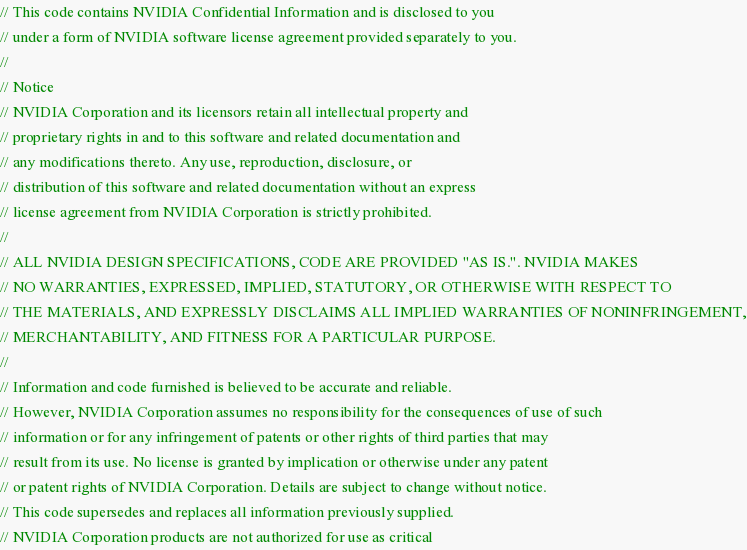Convert code to text. <code><loc_0><loc_0><loc_500><loc_500><_C_>// This code contains NVIDIA Confidential Information and is disclosed to you
// under a form of NVIDIA software license agreement provided separately to you.
//
// Notice
// NVIDIA Corporation and its licensors retain all intellectual property and
// proprietary rights in and to this software and related documentation and
// any modifications thereto. Any use, reproduction, disclosure, or
// distribution of this software and related documentation without an express
// license agreement from NVIDIA Corporation is strictly prohibited.
//
// ALL NVIDIA DESIGN SPECIFICATIONS, CODE ARE PROVIDED "AS IS.". NVIDIA MAKES
// NO WARRANTIES, EXPRESSED, IMPLIED, STATUTORY, OR OTHERWISE WITH RESPECT TO
// THE MATERIALS, AND EXPRESSLY DISCLAIMS ALL IMPLIED WARRANTIES OF NONINFRINGEMENT,
// MERCHANTABILITY, AND FITNESS FOR A PARTICULAR PURPOSE.
//
// Information and code furnished is believed to be accurate and reliable.
// However, NVIDIA Corporation assumes no responsibility for the consequences of use of such
// information or for any infringement of patents or other rights of third parties that may
// result from its use. No license is granted by implication or otherwise under any patent
// or patent rights of NVIDIA Corporation. Details are subject to change without notice.
// This code supersedes and replaces all information previously supplied.
// NVIDIA Corporation products are not authorized for use as critical</code> 